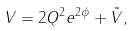Convert formula to latex. <formula><loc_0><loc_0><loc_500><loc_500>V = 2 Q ^ { 2 } e ^ { 2 \phi } + { \tilde { V } } ,</formula> 